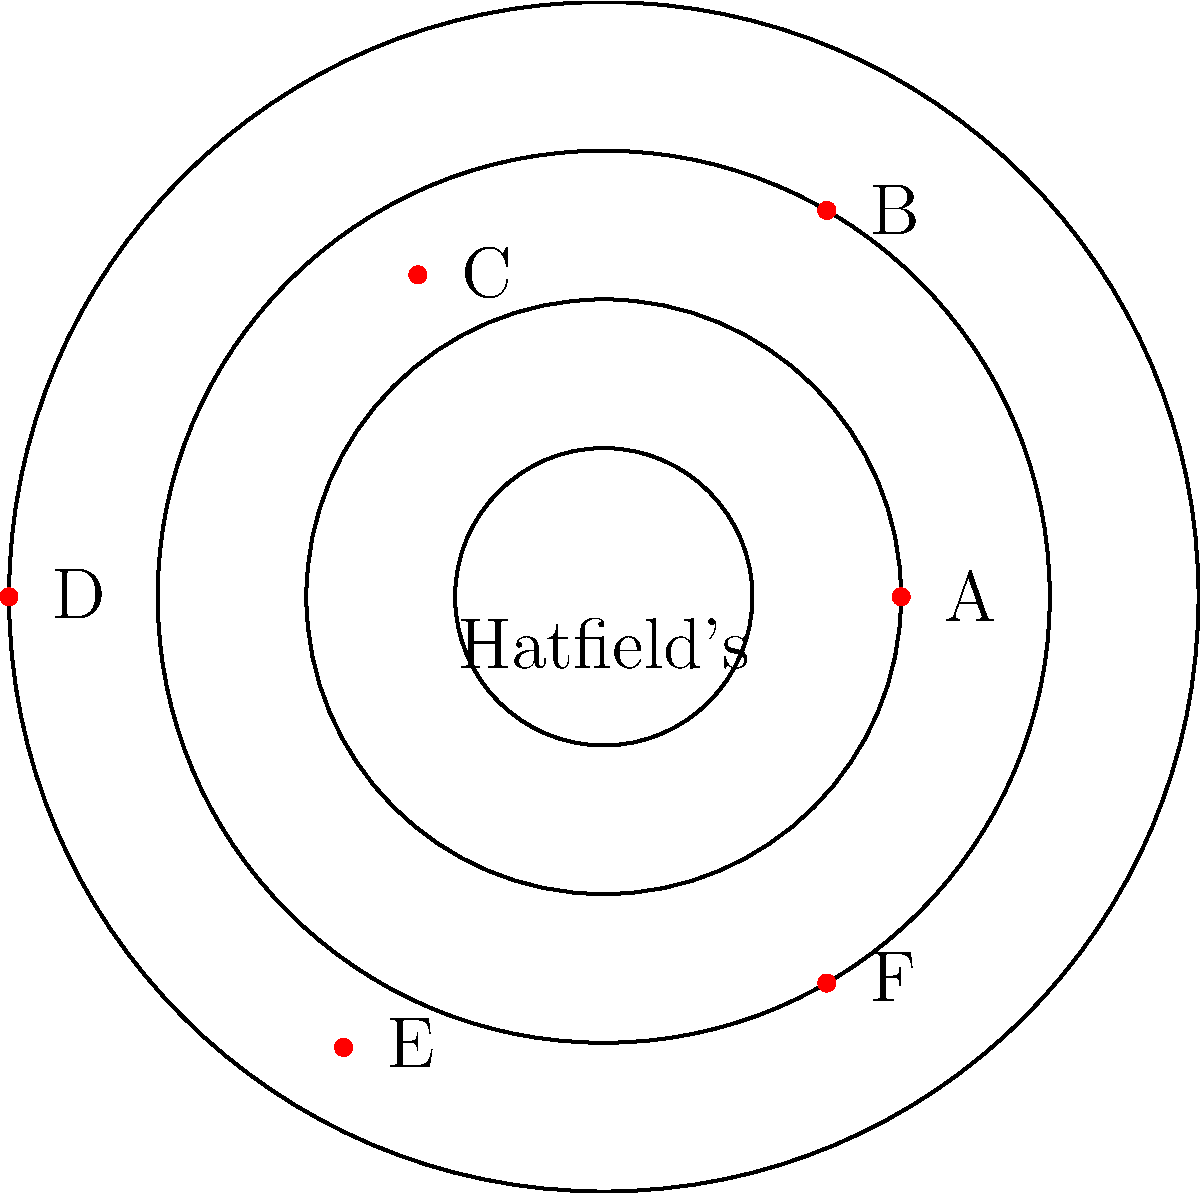In the polar coordinate system shown, where Hatfield's former location is at the origin, which restaurant is located at coordinates $(3, \frac{\pi}{3})$? To answer this question, we need to understand how to read polar coordinates and identify the correct point on the graph. Let's break it down step-by-step:

1. Polar coordinates are given in the form $(r, \theta)$, where:
   - $r$ is the distance from the origin (Hatfield's location in this case)
   - $\theta$ is the angle from the positive x-axis (measured counterclockwise)

2. We're looking for the point with coordinates $(3, \frac{\pi}{3})$:
   - The distance from the origin is 3 units
   - The angle is $\frac{\pi}{3}$ radians (or 60 degrees)

3. On the graph:
   - The concentric circles represent distances from the origin (1, 2, 3, and 4 units)
   - The angles are measured counterclockwise from the positive x-axis

4. Tracing from the origin:
   - Move 3 units outward (to the third circle)
   - Rotate counterclockwise by $\frac{\pi}{3}$ radians (60 degrees)

5. This point corresponds to the location marked as restaurant "B" on the graph.

Therefore, restaurant B is located at coordinates $(3, \frac{\pi}{3})$.
Answer: B 